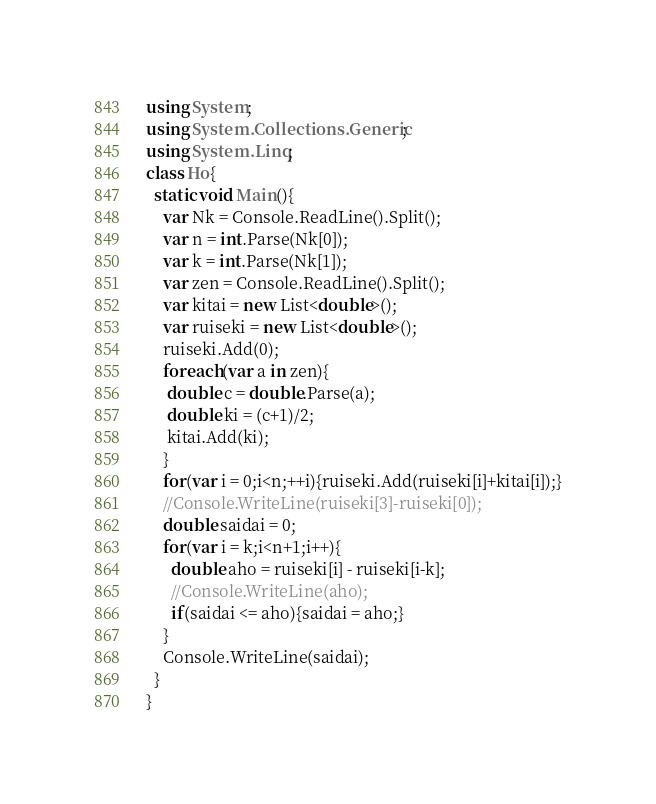Convert code to text. <code><loc_0><loc_0><loc_500><loc_500><_C#_>using System;
using System.Collections.Generic;
using System.Linq;
class Ho{
  static void Main(){
    var Nk = Console.ReadLine().Split();
    var n = int.Parse(Nk[0]);
    var k = int.Parse(Nk[1]);
    var zen = Console.ReadLine().Split();
    var kitai = new List<double>();
    var ruiseki = new List<double>();
    ruiseki.Add(0);
    foreach(var a in zen){
     double c = double.Parse(a);
     double ki = (c+1)/2;
     kitai.Add(ki);
    }
    for(var i = 0;i<n;++i){ruiseki.Add(ruiseki[i]+kitai[i]);}
    //Console.WriteLine(ruiseki[3]-ruiseki[0]);
    double saidai = 0;
    for(var i = k;i<n+1;i++){
      double aho = ruiseki[i] - ruiseki[i-k];
      //Console.WriteLine(aho);
      if(saidai <= aho){saidai = aho;}
    }
    Console.WriteLine(saidai);
  }
}</code> 